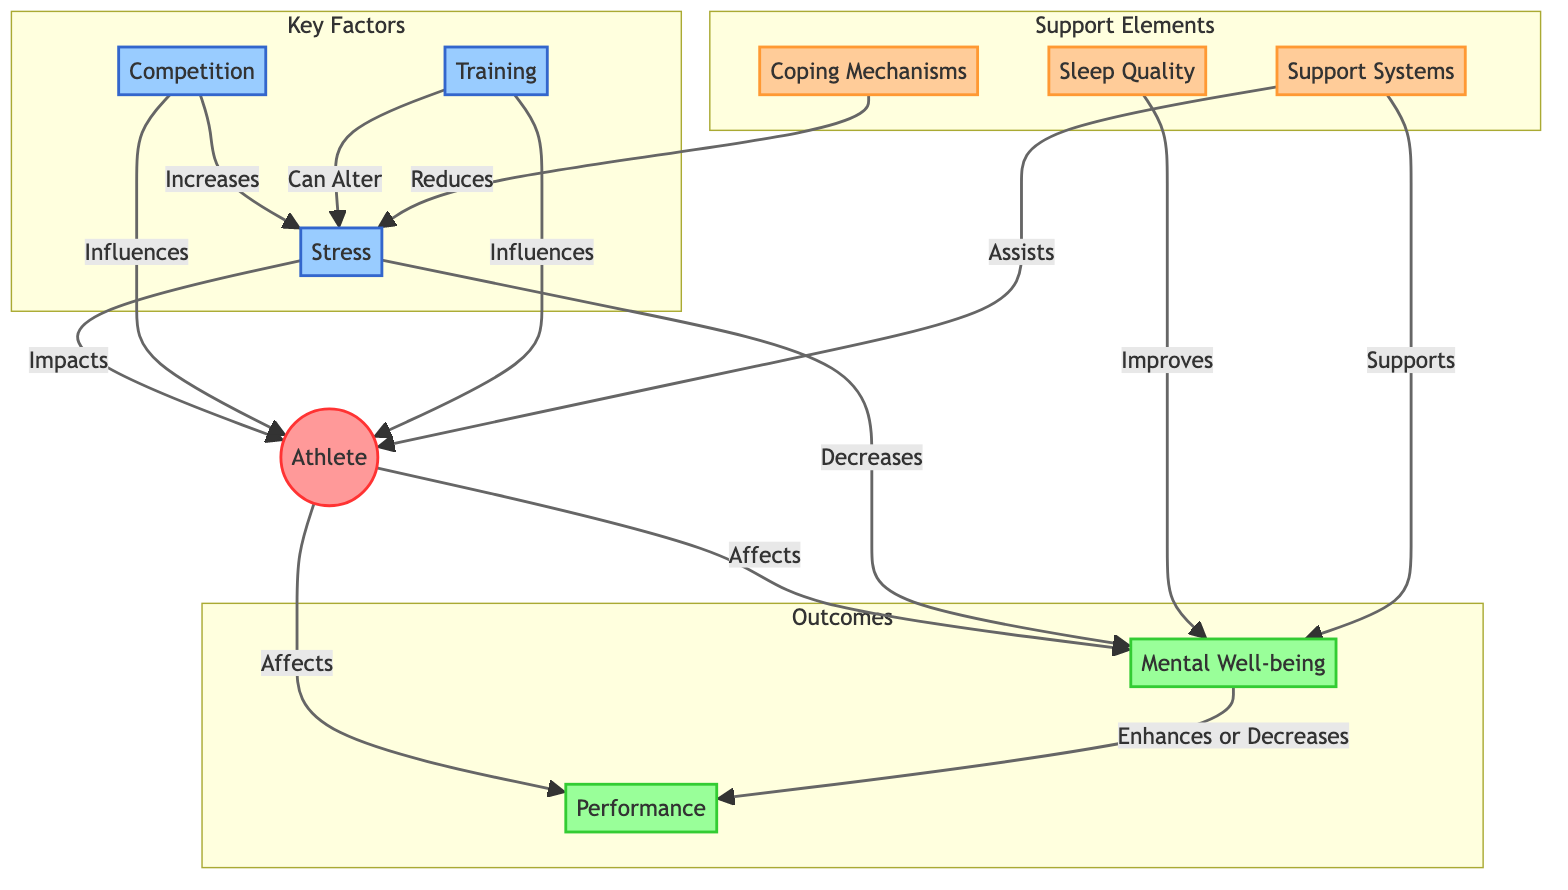What are the three key factors affecting the athlete? The diagram lists three factors: Stress, Competition, and Training, all categorically linked to the athlete's experience and impact.
Answer: Stress, Competition, Training How does Stress influence Mental Well-being? The diagram shows a direct influence where Stress decreases Mental Well-being, indicating a negative relationship between these two nodes.
Answer: Decreases Which element improves Mental Well-being? From the diagram, Sleep Quality is the connecting factor that has an improving effect on Mental Well-being, as shown by the arrow leading from Sleep Quality to Mental Well-being.
Answer: Improves What effect does Competition have on Stress levels? The diagram indicates that Competition increases Stress, which connects the two nodes in a direct causal manner.
Answer: Increases How many support elements are in the diagram? The diagram highlights three support elements: Sleep Quality, Coping Mechanisms, and Support Systems, with each categorized under the Support Elements subgraph.
Answer: 3 What relationship exists between Mental Well-being and Performance? The diagram implies that Mental Well-being enhances or decreases Performance, suggesting a dependent relationship where the state of Mental Well-being directly affects performance levels.
Answer: Enhances or Decreases What role do Coping Mechanisms play in relation to Stress? According to the diagram, Coping Mechanisms reduce Stress, demonstrating how they function in a supportive capacity towards mitigating stress factors for the athlete.
Answer: Reduces Which factor can alter Stress levels? The diagram shows that Training can alter Stress, indicating that it serves as a variable that can influence the degree of stress experienced.
Answer: Can Alter Which support system assists both Mental Well-being and the Athlete? The diagram indicates that Support Systems have two arrows showing that they support Mental Well-being and assist the athlete, reflecting their dual role.
Answer: Supports, Assists 